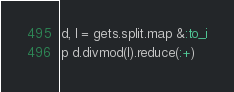Convert code to text. <code><loc_0><loc_0><loc_500><loc_500><_Ruby_>d, l = gets.split.map &:to_i
p d.divmod(l).reduce(:+)</code> 